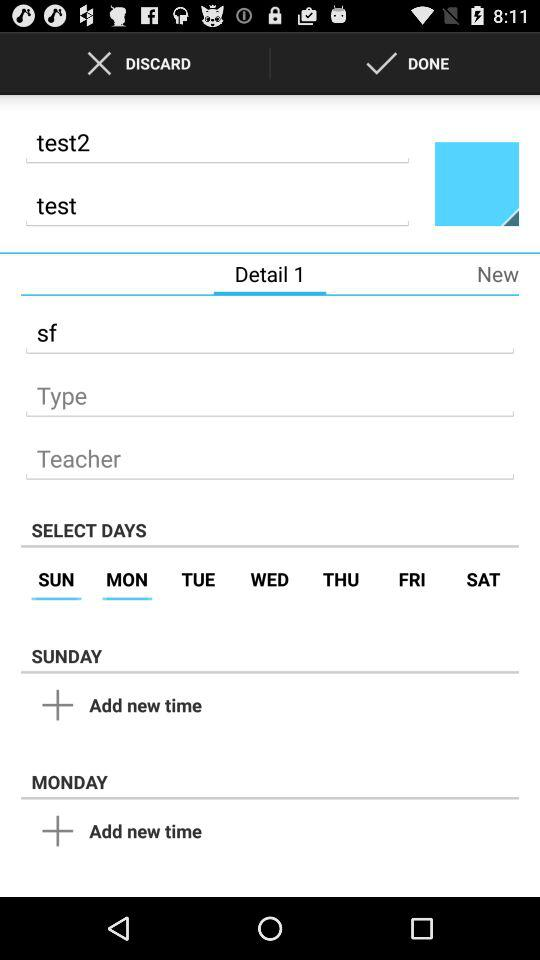How many days are selected?
Answer the question using a single word or phrase. 2 